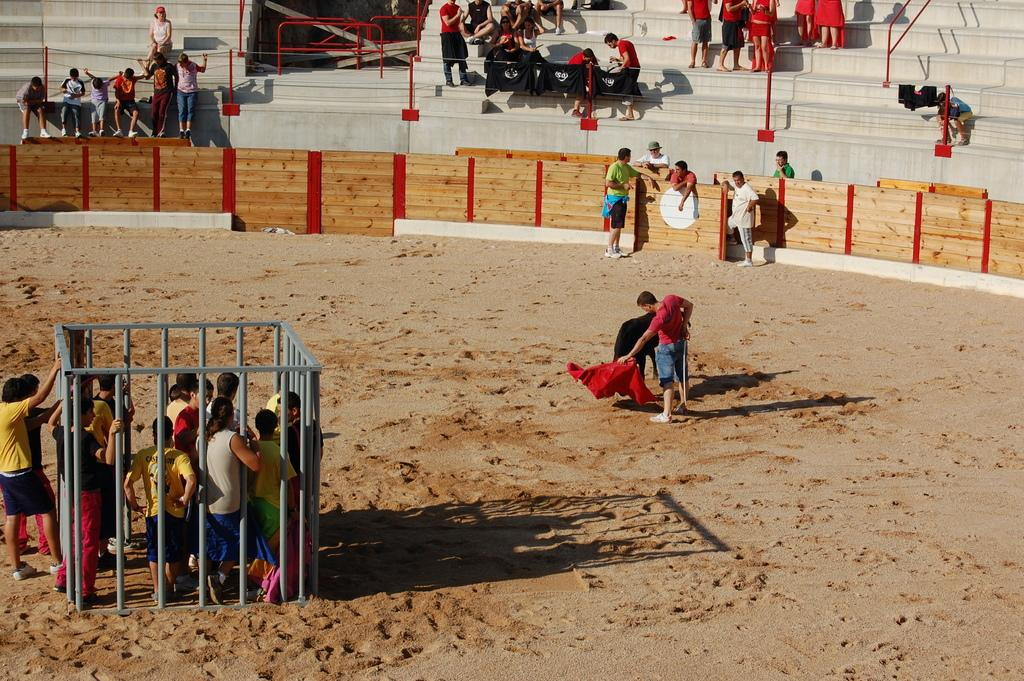What is the setting of the image? The setting of the image is a playground. What are the people in the playground doing? There are people standing in the playground. Are there any specific features or structures in the playground? Yes, there is a cage around some persons. Where are the audience members located in the image? The audience members are sitting on the stairs. What type of drug can be seen in the hands of the person in the cage? There is no drug present in the image; it features people standing in a playground with a cage around some persons. What type of collar is the person in the cage wearing? There is no collar visible on any person in the image. 